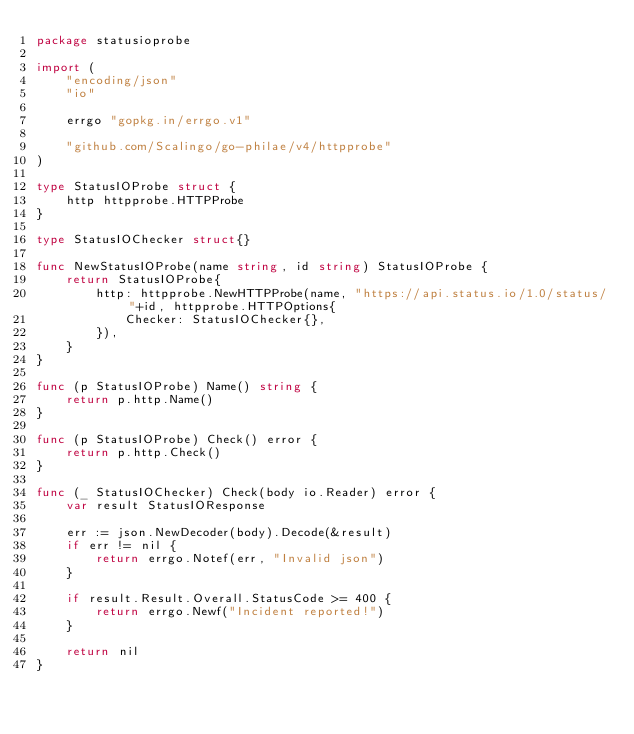Convert code to text. <code><loc_0><loc_0><loc_500><loc_500><_Go_>package statusioprobe

import (
	"encoding/json"
	"io"

	errgo "gopkg.in/errgo.v1"

	"github.com/Scalingo/go-philae/v4/httpprobe"
)

type StatusIOProbe struct {
	http httpprobe.HTTPProbe
}

type StatusIOChecker struct{}

func NewStatusIOProbe(name string, id string) StatusIOProbe {
	return StatusIOProbe{
		http: httpprobe.NewHTTPProbe(name, "https://api.status.io/1.0/status/"+id, httpprobe.HTTPOptions{
			Checker: StatusIOChecker{},
		}),
	}
}

func (p StatusIOProbe) Name() string {
	return p.http.Name()
}

func (p StatusIOProbe) Check() error {
	return p.http.Check()
}

func (_ StatusIOChecker) Check(body io.Reader) error {
	var result StatusIOResponse

	err := json.NewDecoder(body).Decode(&result)
	if err != nil {
		return errgo.Notef(err, "Invalid json")
	}

	if result.Result.Overall.StatusCode >= 400 {
		return errgo.Newf("Incident reported!")
	}

	return nil
}
</code> 